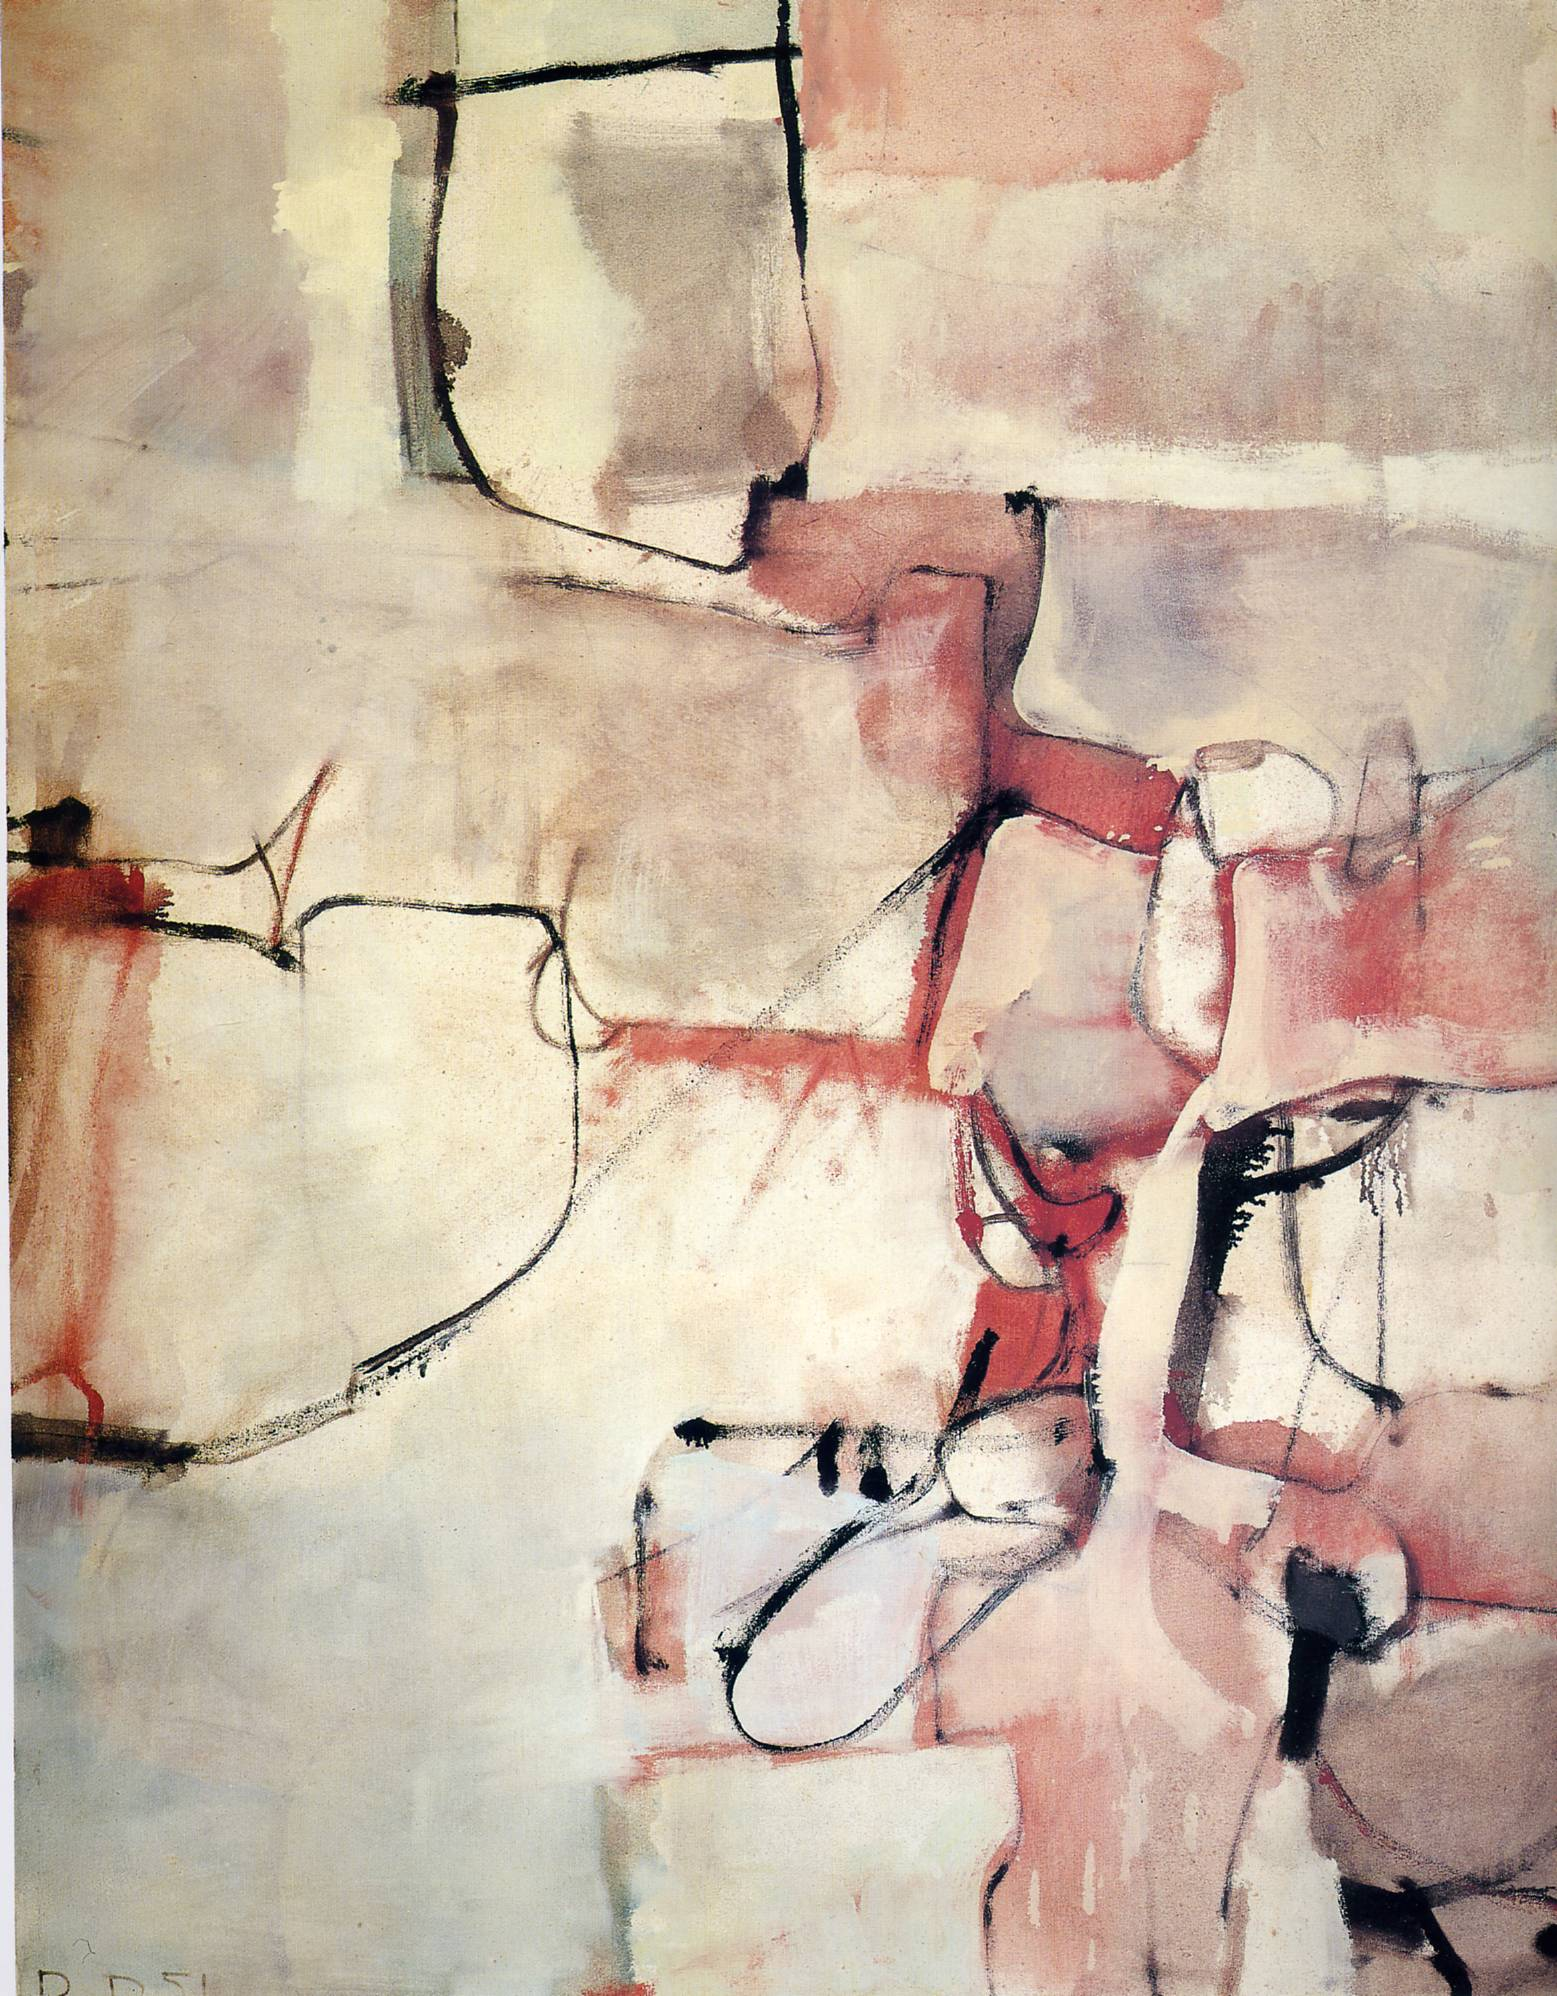What emotions do you think the artist was trying to convey through this abstract artwork? The artist appears to employ a palette of reds and soft beige to evoke feelings of warmth and perhaps a sense of unrest or conflict, suggested by the chaotic intersecting lines. The gentle blending of these colors with the harsh black lines may be conveying a complex mix of emotions, possibly reflecting on themes of fragmentation or the complexity of human emotions. 